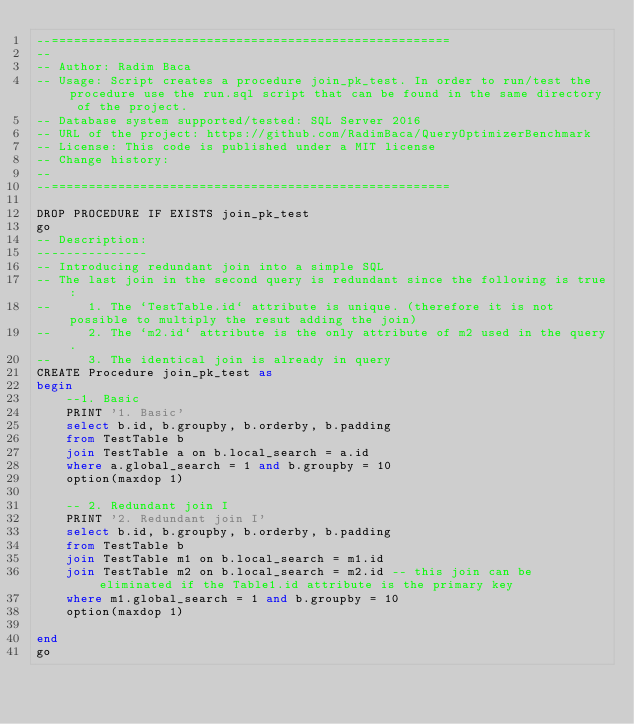<code> <loc_0><loc_0><loc_500><loc_500><_SQL_>--======================================================
--
-- Author: Radim Baca
-- Usage: Script creates a procedure join_pk_test. In order to run/test the procedure use the run.sql script that can be found in the same directory of the project.
-- Database system supported/tested: SQL Server 2016
-- URL of the project: https://github.com/RadimBaca/QueryOptimizerBenchmark
-- License: This code is published under a MIT license
-- Change history:
--
--======================================================

DROP PROCEDURE IF EXISTS join_pk_test
go
-- Description: 
---------------
-- Introducing redundant join into a simple SQL
-- The last join in the second query is redundant since the following is true:
--     1. The `TestTable.id` attribute is unique. (therefore it is not possible to multiply the resut adding the join)
--     2. The `m2.id` attribute is the only attribute of m2 used in the query.
--     3. The identical join is already in query
CREATE Procedure join_pk_test as
begin
	--1. Basic
	PRINT '1. Basic'
	select b.id, b.groupby, b.orderby, b.padding
	from TestTable b
	join TestTable a on b.local_search = a.id
	where a.global_search = 1 and b.groupby = 10
	option(maxdop 1)

	-- 2. Redundant join I 
	PRINT '2. Redundant join I'
	select b.id, b.groupby, b.orderby, b.padding
	from TestTable b
	join TestTable m1 on b.local_search = m1.id
	join TestTable m2 on b.local_search = m2.id -- this join can be eliminated if the Table1.id attribute is the primary key
	where m1.global_search = 1 and b.groupby = 10
	option(maxdop 1)

end
go

</code> 